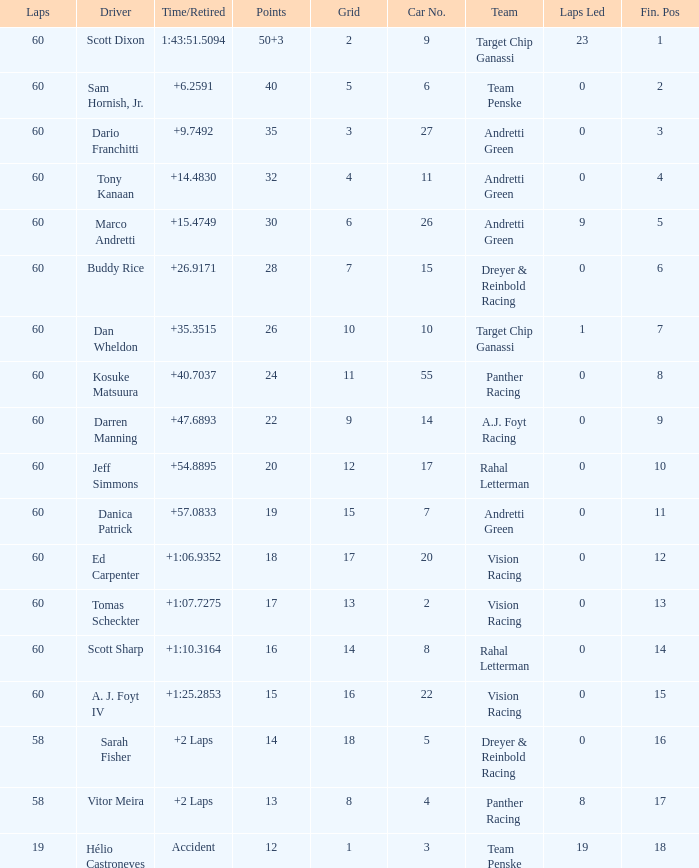Name the laps for 18 pointss 60.0. 